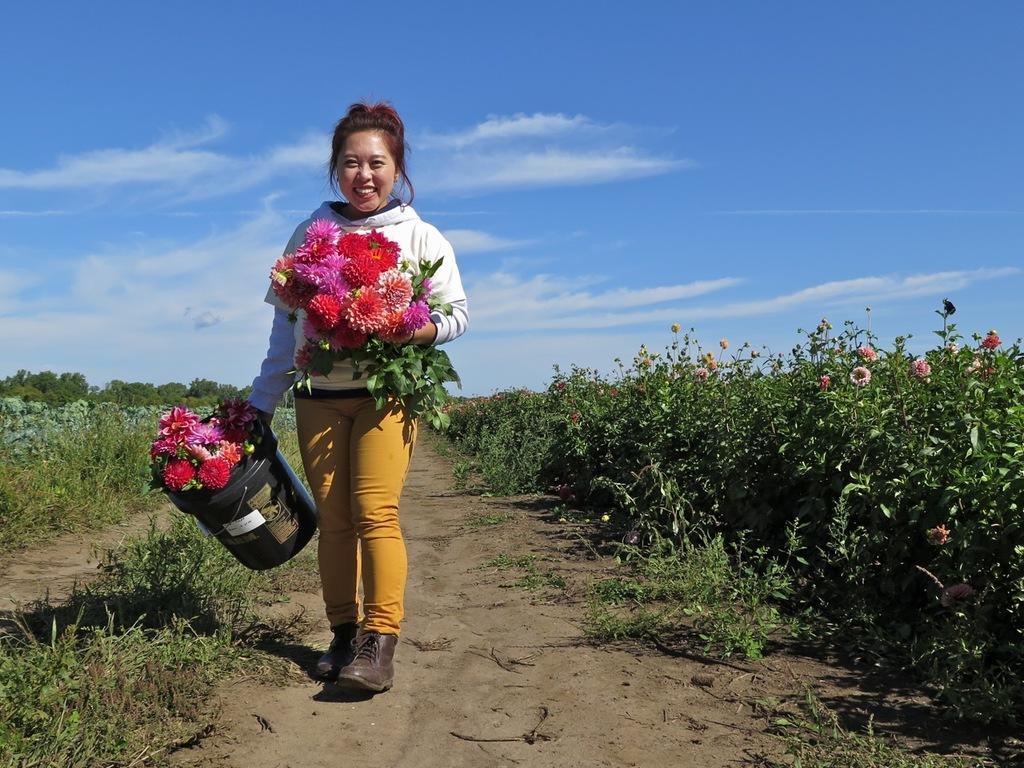Please provide a concise description of this image. In this image I can see the person standing on the ground. The person is wearing the white and yellow color dress and also holding the flowers which are in red, pink and white color. She is also holding the bucket. To the side of the person there are many plants with flowers. In the background I can see the clouds and the blue sky. 